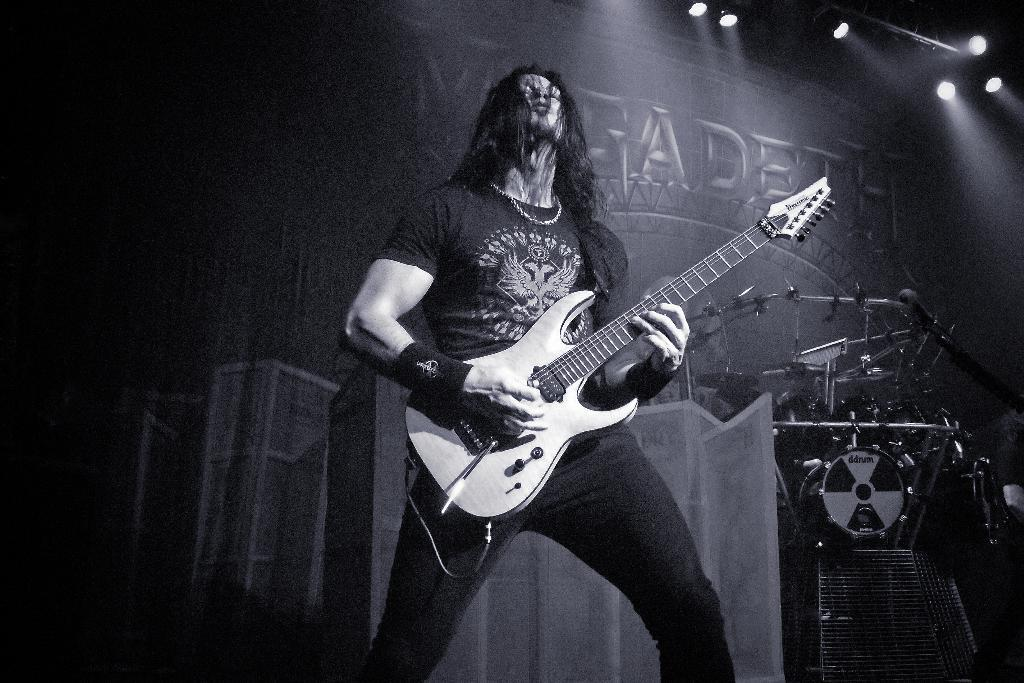What is the main subject of the image? There is a man in the image. What is the man doing in the image? The man is standing and playing a guitar. What other musical instrument can be seen in the background of the image? There are drums in the background of the image. What type of zephyr can be seen blowing through the man's hair in the image? There is no zephyr present in the image, and the man's hair is not being blown by any wind. How many planes are visible in the image? There are no planes visible in the image; it features a man playing a guitar and drums in the background. 